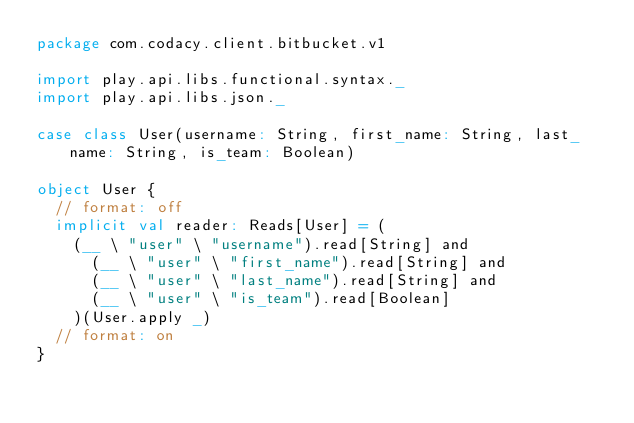<code> <loc_0><loc_0><loc_500><loc_500><_Scala_>package com.codacy.client.bitbucket.v1

import play.api.libs.functional.syntax._
import play.api.libs.json._

case class User(username: String, first_name: String, last_name: String, is_team: Boolean)

object User {
  // format: off
  implicit val reader: Reads[User] = (
    (__ \ "user" \ "username").read[String] and
      (__ \ "user" \ "first_name").read[String] and
      (__ \ "user" \ "last_name").read[String] and
      (__ \ "user" \ "is_team").read[Boolean]
    )(User.apply _)
  // format: on
}
</code> 